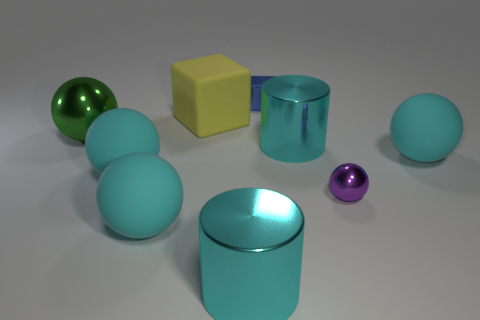How many cyan cylinders must be subtracted to get 1 cyan cylinders? 1 Subtract all metallic balls. How many balls are left? 3 Subtract all brown cylinders. How many cyan spheres are left? 3 Subtract all blue cubes. How many cubes are left? 1 Add 1 purple spheres. How many objects exist? 10 Subtract all cylinders. How many objects are left? 7 Subtract 0 red cubes. How many objects are left? 9 Subtract all yellow cubes. Subtract all brown cylinders. How many cubes are left? 1 Subtract all tiny purple objects. Subtract all small things. How many objects are left? 6 Add 2 green shiny spheres. How many green shiny spheres are left? 3 